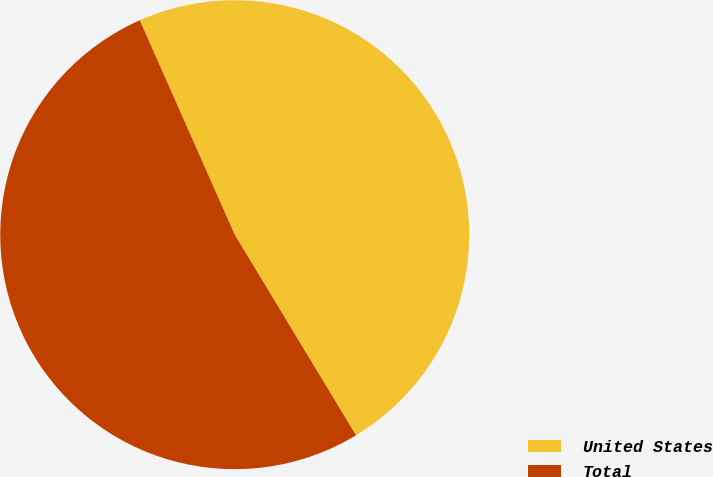<chart> <loc_0><loc_0><loc_500><loc_500><pie_chart><fcel>United States<fcel>Total<nl><fcel>47.98%<fcel>52.02%<nl></chart> 